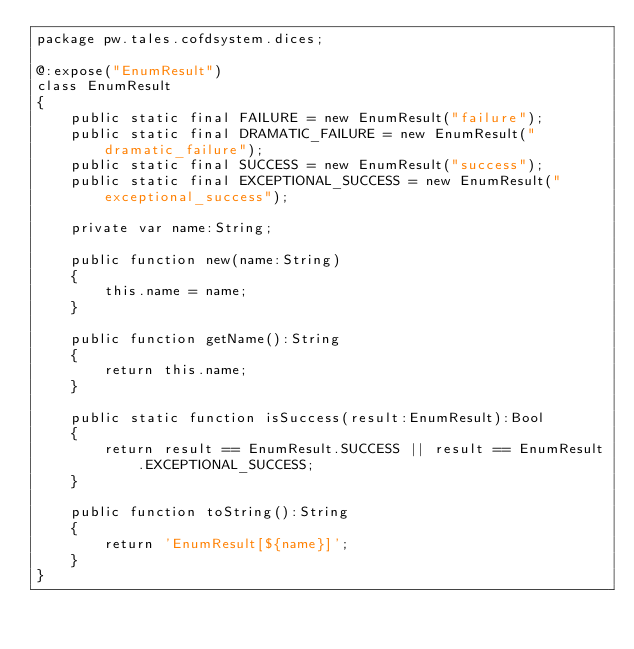Convert code to text. <code><loc_0><loc_0><loc_500><loc_500><_Haxe_>package pw.tales.cofdsystem.dices;

@:expose("EnumResult")
class EnumResult
{
    public static final FAILURE = new EnumResult("failure");
    public static final DRAMATIC_FAILURE = new EnumResult("dramatic_failure");
    public static final SUCCESS = new EnumResult("success");
    public static final EXCEPTIONAL_SUCCESS = new EnumResult("exceptional_success");

    private var name:String;

    public function new(name:String)
    {
        this.name = name;
    }

    public function getName():String
    {
        return this.name;
    }

    public static function isSuccess(result:EnumResult):Bool
    {
        return result == EnumResult.SUCCESS || result == EnumResult.EXCEPTIONAL_SUCCESS;
    }

    public function toString():String
    {
        return 'EnumResult[${name}]';
    }
}
</code> 